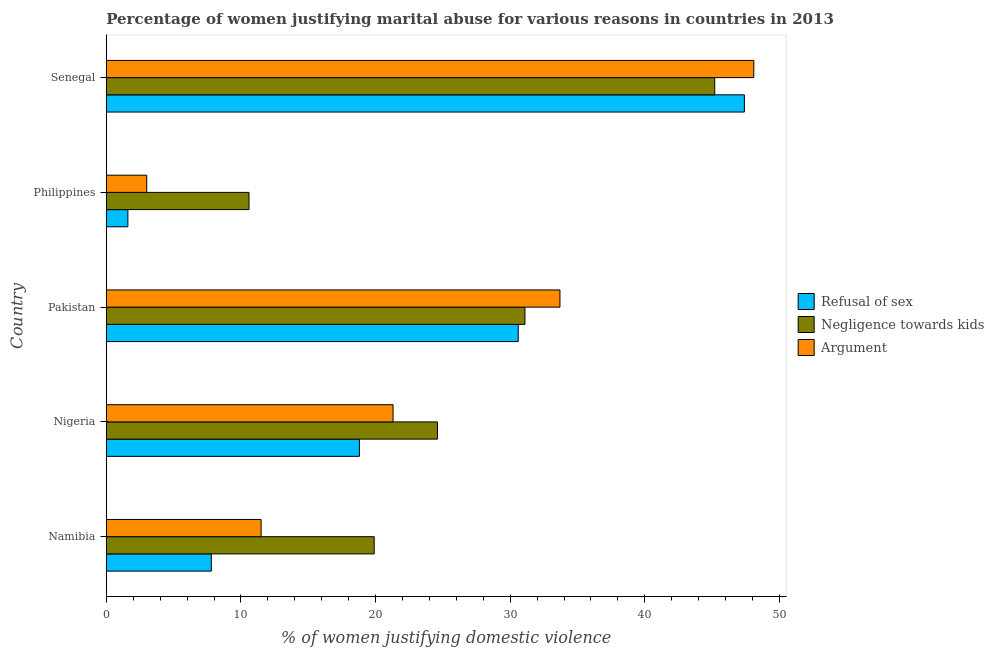How many different coloured bars are there?
Ensure brevity in your answer.  3. How many groups of bars are there?
Make the answer very short. 5. Are the number of bars per tick equal to the number of legend labels?
Keep it short and to the point. Yes. What is the label of the 5th group of bars from the top?
Offer a terse response. Namibia. What is the percentage of women justifying domestic violence due to arguments in Pakistan?
Provide a short and direct response. 33.7. Across all countries, what is the maximum percentage of women justifying domestic violence due to arguments?
Offer a terse response. 48.1. Across all countries, what is the minimum percentage of women justifying domestic violence due to arguments?
Provide a succinct answer. 3. In which country was the percentage of women justifying domestic violence due to refusal of sex maximum?
Give a very brief answer. Senegal. In which country was the percentage of women justifying domestic violence due to refusal of sex minimum?
Keep it short and to the point. Philippines. What is the total percentage of women justifying domestic violence due to arguments in the graph?
Your answer should be compact. 117.6. What is the difference between the percentage of women justifying domestic violence due to refusal of sex in Nigeria and the percentage of women justifying domestic violence due to arguments in Senegal?
Keep it short and to the point. -29.3. What is the average percentage of women justifying domestic violence due to arguments per country?
Your answer should be compact. 23.52. What is the ratio of the percentage of women justifying domestic violence due to refusal of sex in Pakistan to that in Senegal?
Give a very brief answer. 0.65. What is the difference between the highest and the second highest percentage of women justifying domestic violence due to refusal of sex?
Offer a terse response. 16.8. What is the difference between the highest and the lowest percentage of women justifying domestic violence due to arguments?
Provide a short and direct response. 45.1. In how many countries, is the percentage of women justifying domestic violence due to negligence towards kids greater than the average percentage of women justifying domestic violence due to negligence towards kids taken over all countries?
Make the answer very short. 2. Is the sum of the percentage of women justifying domestic violence due to arguments in Nigeria and Philippines greater than the maximum percentage of women justifying domestic violence due to refusal of sex across all countries?
Offer a very short reply. No. What does the 2nd bar from the top in Senegal represents?
Provide a short and direct response. Negligence towards kids. What does the 2nd bar from the bottom in Nigeria represents?
Keep it short and to the point. Negligence towards kids. How many countries are there in the graph?
Give a very brief answer. 5. What is the difference between two consecutive major ticks on the X-axis?
Your answer should be compact. 10. Are the values on the major ticks of X-axis written in scientific E-notation?
Ensure brevity in your answer.  No. Where does the legend appear in the graph?
Offer a terse response. Center right. How many legend labels are there?
Give a very brief answer. 3. How are the legend labels stacked?
Your response must be concise. Vertical. What is the title of the graph?
Keep it short and to the point. Percentage of women justifying marital abuse for various reasons in countries in 2013. What is the label or title of the X-axis?
Provide a short and direct response. % of women justifying domestic violence. What is the label or title of the Y-axis?
Make the answer very short. Country. What is the % of women justifying domestic violence in Negligence towards kids in Namibia?
Ensure brevity in your answer.  19.9. What is the % of women justifying domestic violence in Refusal of sex in Nigeria?
Keep it short and to the point. 18.8. What is the % of women justifying domestic violence of Negligence towards kids in Nigeria?
Offer a terse response. 24.6. What is the % of women justifying domestic violence in Argument in Nigeria?
Your answer should be compact. 21.3. What is the % of women justifying domestic violence of Refusal of sex in Pakistan?
Provide a short and direct response. 30.6. What is the % of women justifying domestic violence in Negligence towards kids in Pakistan?
Your answer should be compact. 31.1. What is the % of women justifying domestic violence of Argument in Pakistan?
Your answer should be compact. 33.7. What is the % of women justifying domestic violence of Refusal of sex in Philippines?
Offer a very short reply. 1.6. What is the % of women justifying domestic violence in Argument in Philippines?
Provide a succinct answer. 3. What is the % of women justifying domestic violence of Refusal of sex in Senegal?
Provide a succinct answer. 47.4. What is the % of women justifying domestic violence in Negligence towards kids in Senegal?
Ensure brevity in your answer.  45.2. What is the % of women justifying domestic violence in Argument in Senegal?
Offer a very short reply. 48.1. Across all countries, what is the maximum % of women justifying domestic violence of Refusal of sex?
Keep it short and to the point. 47.4. Across all countries, what is the maximum % of women justifying domestic violence of Negligence towards kids?
Your answer should be very brief. 45.2. Across all countries, what is the maximum % of women justifying domestic violence in Argument?
Provide a short and direct response. 48.1. Across all countries, what is the minimum % of women justifying domestic violence in Refusal of sex?
Your answer should be very brief. 1.6. Across all countries, what is the minimum % of women justifying domestic violence in Negligence towards kids?
Offer a very short reply. 10.6. What is the total % of women justifying domestic violence of Refusal of sex in the graph?
Give a very brief answer. 106.2. What is the total % of women justifying domestic violence in Negligence towards kids in the graph?
Your response must be concise. 131.4. What is the total % of women justifying domestic violence in Argument in the graph?
Ensure brevity in your answer.  117.6. What is the difference between the % of women justifying domestic violence in Refusal of sex in Namibia and that in Pakistan?
Your answer should be compact. -22.8. What is the difference between the % of women justifying domestic violence in Argument in Namibia and that in Pakistan?
Offer a very short reply. -22.2. What is the difference between the % of women justifying domestic violence in Negligence towards kids in Namibia and that in Philippines?
Your response must be concise. 9.3. What is the difference between the % of women justifying domestic violence of Argument in Namibia and that in Philippines?
Keep it short and to the point. 8.5. What is the difference between the % of women justifying domestic violence in Refusal of sex in Namibia and that in Senegal?
Offer a very short reply. -39.6. What is the difference between the % of women justifying domestic violence in Negligence towards kids in Namibia and that in Senegal?
Provide a succinct answer. -25.3. What is the difference between the % of women justifying domestic violence of Argument in Namibia and that in Senegal?
Offer a very short reply. -36.6. What is the difference between the % of women justifying domestic violence in Argument in Nigeria and that in Pakistan?
Your answer should be very brief. -12.4. What is the difference between the % of women justifying domestic violence of Negligence towards kids in Nigeria and that in Philippines?
Provide a short and direct response. 14. What is the difference between the % of women justifying domestic violence in Refusal of sex in Nigeria and that in Senegal?
Make the answer very short. -28.6. What is the difference between the % of women justifying domestic violence in Negligence towards kids in Nigeria and that in Senegal?
Offer a terse response. -20.6. What is the difference between the % of women justifying domestic violence of Argument in Nigeria and that in Senegal?
Offer a terse response. -26.8. What is the difference between the % of women justifying domestic violence of Refusal of sex in Pakistan and that in Philippines?
Your answer should be compact. 29. What is the difference between the % of women justifying domestic violence of Argument in Pakistan and that in Philippines?
Provide a succinct answer. 30.7. What is the difference between the % of women justifying domestic violence of Refusal of sex in Pakistan and that in Senegal?
Offer a terse response. -16.8. What is the difference between the % of women justifying domestic violence in Negligence towards kids in Pakistan and that in Senegal?
Ensure brevity in your answer.  -14.1. What is the difference between the % of women justifying domestic violence in Argument in Pakistan and that in Senegal?
Offer a terse response. -14.4. What is the difference between the % of women justifying domestic violence of Refusal of sex in Philippines and that in Senegal?
Keep it short and to the point. -45.8. What is the difference between the % of women justifying domestic violence of Negligence towards kids in Philippines and that in Senegal?
Give a very brief answer. -34.6. What is the difference between the % of women justifying domestic violence in Argument in Philippines and that in Senegal?
Keep it short and to the point. -45.1. What is the difference between the % of women justifying domestic violence in Refusal of sex in Namibia and the % of women justifying domestic violence in Negligence towards kids in Nigeria?
Your answer should be very brief. -16.8. What is the difference between the % of women justifying domestic violence of Refusal of sex in Namibia and the % of women justifying domestic violence of Argument in Nigeria?
Make the answer very short. -13.5. What is the difference between the % of women justifying domestic violence of Refusal of sex in Namibia and the % of women justifying domestic violence of Negligence towards kids in Pakistan?
Your response must be concise. -23.3. What is the difference between the % of women justifying domestic violence in Refusal of sex in Namibia and the % of women justifying domestic violence in Argument in Pakistan?
Offer a very short reply. -25.9. What is the difference between the % of women justifying domestic violence of Negligence towards kids in Namibia and the % of women justifying domestic violence of Argument in Pakistan?
Your answer should be very brief. -13.8. What is the difference between the % of women justifying domestic violence of Refusal of sex in Namibia and the % of women justifying domestic violence of Negligence towards kids in Philippines?
Provide a succinct answer. -2.8. What is the difference between the % of women justifying domestic violence in Negligence towards kids in Namibia and the % of women justifying domestic violence in Argument in Philippines?
Your response must be concise. 16.9. What is the difference between the % of women justifying domestic violence in Refusal of sex in Namibia and the % of women justifying domestic violence in Negligence towards kids in Senegal?
Your answer should be compact. -37.4. What is the difference between the % of women justifying domestic violence in Refusal of sex in Namibia and the % of women justifying domestic violence in Argument in Senegal?
Your response must be concise. -40.3. What is the difference between the % of women justifying domestic violence in Negligence towards kids in Namibia and the % of women justifying domestic violence in Argument in Senegal?
Your answer should be compact. -28.2. What is the difference between the % of women justifying domestic violence in Refusal of sex in Nigeria and the % of women justifying domestic violence in Negligence towards kids in Pakistan?
Offer a terse response. -12.3. What is the difference between the % of women justifying domestic violence in Refusal of sex in Nigeria and the % of women justifying domestic violence in Argument in Pakistan?
Provide a short and direct response. -14.9. What is the difference between the % of women justifying domestic violence in Refusal of sex in Nigeria and the % of women justifying domestic violence in Negligence towards kids in Philippines?
Make the answer very short. 8.2. What is the difference between the % of women justifying domestic violence of Refusal of sex in Nigeria and the % of women justifying domestic violence of Argument in Philippines?
Make the answer very short. 15.8. What is the difference between the % of women justifying domestic violence in Negligence towards kids in Nigeria and the % of women justifying domestic violence in Argument in Philippines?
Offer a terse response. 21.6. What is the difference between the % of women justifying domestic violence in Refusal of sex in Nigeria and the % of women justifying domestic violence in Negligence towards kids in Senegal?
Give a very brief answer. -26.4. What is the difference between the % of women justifying domestic violence of Refusal of sex in Nigeria and the % of women justifying domestic violence of Argument in Senegal?
Offer a very short reply. -29.3. What is the difference between the % of women justifying domestic violence of Negligence towards kids in Nigeria and the % of women justifying domestic violence of Argument in Senegal?
Offer a very short reply. -23.5. What is the difference between the % of women justifying domestic violence of Refusal of sex in Pakistan and the % of women justifying domestic violence of Negligence towards kids in Philippines?
Provide a short and direct response. 20. What is the difference between the % of women justifying domestic violence in Refusal of sex in Pakistan and the % of women justifying domestic violence in Argument in Philippines?
Offer a very short reply. 27.6. What is the difference between the % of women justifying domestic violence of Negligence towards kids in Pakistan and the % of women justifying domestic violence of Argument in Philippines?
Your answer should be very brief. 28.1. What is the difference between the % of women justifying domestic violence of Refusal of sex in Pakistan and the % of women justifying domestic violence of Negligence towards kids in Senegal?
Offer a very short reply. -14.6. What is the difference between the % of women justifying domestic violence of Refusal of sex in Pakistan and the % of women justifying domestic violence of Argument in Senegal?
Make the answer very short. -17.5. What is the difference between the % of women justifying domestic violence in Negligence towards kids in Pakistan and the % of women justifying domestic violence in Argument in Senegal?
Make the answer very short. -17. What is the difference between the % of women justifying domestic violence of Refusal of sex in Philippines and the % of women justifying domestic violence of Negligence towards kids in Senegal?
Your answer should be very brief. -43.6. What is the difference between the % of women justifying domestic violence in Refusal of sex in Philippines and the % of women justifying domestic violence in Argument in Senegal?
Give a very brief answer. -46.5. What is the difference between the % of women justifying domestic violence of Negligence towards kids in Philippines and the % of women justifying domestic violence of Argument in Senegal?
Provide a short and direct response. -37.5. What is the average % of women justifying domestic violence of Refusal of sex per country?
Your answer should be very brief. 21.24. What is the average % of women justifying domestic violence in Negligence towards kids per country?
Provide a succinct answer. 26.28. What is the average % of women justifying domestic violence of Argument per country?
Provide a short and direct response. 23.52. What is the difference between the % of women justifying domestic violence in Refusal of sex and % of women justifying domestic violence in Negligence towards kids in Namibia?
Give a very brief answer. -12.1. What is the difference between the % of women justifying domestic violence of Negligence towards kids and % of women justifying domestic violence of Argument in Namibia?
Your answer should be compact. 8.4. What is the difference between the % of women justifying domestic violence of Refusal of sex and % of women justifying domestic violence of Argument in Nigeria?
Offer a very short reply. -2.5. What is the difference between the % of women justifying domestic violence in Negligence towards kids and % of women justifying domestic violence in Argument in Nigeria?
Offer a very short reply. 3.3. What is the difference between the % of women justifying domestic violence of Refusal of sex and % of women justifying domestic violence of Argument in Pakistan?
Make the answer very short. -3.1. What is the difference between the % of women justifying domestic violence of Negligence towards kids and % of women justifying domestic violence of Argument in Pakistan?
Give a very brief answer. -2.6. What is the difference between the % of women justifying domestic violence in Refusal of sex and % of women justifying domestic violence in Negligence towards kids in Philippines?
Provide a short and direct response. -9. What is the difference between the % of women justifying domestic violence of Refusal of sex and % of women justifying domestic violence of Argument in Senegal?
Offer a terse response. -0.7. What is the ratio of the % of women justifying domestic violence of Refusal of sex in Namibia to that in Nigeria?
Your response must be concise. 0.41. What is the ratio of the % of women justifying domestic violence in Negligence towards kids in Namibia to that in Nigeria?
Offer a very short reply. 0.81. What is the ratio of the % of women justifying domestic violence of Argument in Namibia to that in Nigeria?
Offer a terse response. 0.54. What is the ratio of the % of women justifying domestic violence of Refusal of sex in Namibia to that in Pakistan?
Your answer should be compact. 0.25. What is the ratio of the % of women justifying domestic violence in Negligence towards kids in Namibia to that in Pakistan?
Give a very brief answer. 0.64. What is the ratio of the % of women justifying domestic violence in Argument in Namibia to that in Pakistan?
Provide a succinct answer. 0.34. What is the ratio of the % of women justifying domestic violence in Refusal of sex in Namibia to that in Philippines?
Your answer should be very brief. 4.88. What is the ratio of the % of women justifying domestic violence of Negligence towards kids in Namibia to that in Philippines?
Your answer should be very brief. 1.88. What is the ratio of the % of women justifying domestic violence in Argument in Namibia to that in Philippines?
Make the answer very short. 3.83. What is the ratio of the % of women justifying domestic violence in Refusal of sex in Namibia to that in Senegal?
Make the answer very short. 0.16. What is the ratio of the % of women justifying domestic violence in Negligence towards kids in Namibia to that in Senegal?
Your response must be concise. 0.44. What is the ratio of the % of women justifying domestic violence of Argument in Namibia to that in Senegal?
Your response must be concise. 0.24. What is the ratio of the % of women justifying domestic violence of Refusal of sex in Nigeria to that in Pakistan?
Your answer should be very brief. 0.61. What is the ratio of the % of women justifying domestic violence in Negligence towards kids in Nigeria to that in Pakistan?
Offer a terse response. 0.79. What is the ratio of the % of women justifying domestic violence of Argument in Nigeria to that in Pakistan?
Your answer should be compact. 0.63. What is the ratio of the % of women justifying domestic violence of Refusal of sex in Nigeria to that in Philippines?
Your answer should be compact. 11.75. What is the ratio of the % of women justifying domestic violence in Negligence towards kids in Nigeria to that in Philippines?
Ensure brevity in your answer.  2.32. What is the ratio of the % of women justifying domestic violence of Argument in Nigeria to that in Philippines?
Your answer should be compact. 7.1. What is the ratio of the % of women justifying domestic violence in Refusal of sex in Nigeria to that in Senegal?
Provide a succinct answer. 0.4. What is the ratio of the % of women justifying domestic violence of Negligence towards kids in Nigeria to that in Senegal?
Give a very brief answer. 0.54. What is the ratio of the % of women justifying domestic violence in Argument in Nigeria to that in Senegal?
Keep it short and to the point. 0.44. What is the ratio of the % of women justifying domestic violence of Refusal of sex in Pakistan to that in Philippines?
Give a very brief answer. 19.12. What is the ratio of the % of women justifying domestic violence in Negligence towards kids in Pakistan to that in Philippines?
Your response must be concise. 2.93. What is the ratio of the % of women justifying domestic violence of Argument in Pakistan to that in Philippines?
Provide a succinct answer. 11.23. What is the ratio of the % of women justifying domestic violence of Refusal of sex in Pakistan to that in Senegal?
Keep it short and to the point. 0.65. What is the ratio of the % of women justifying domestic violence in Negligence towards kids in Pakistan to that in Senegal?
Give a very brief answer. 0.69. What is the ratio of the % of women justifying domestic violence in Argument in Pakistan to that in Senegal?
Make the answer very short. 0.7. What is the ratio of the % of women justifying domestic violence of Refusal of sex in Philippines to that in Senegal?
Your answer should be very brief. 0.03. What is the ratio of the % of women justifying domestic violence in Negligence towards kids in Philippines to that in Senegal?
Offer a terse response. 0.23. What is the ratio of the % of women justifying domestic violence in Argument in Philippines to that in Senegal?
Give a very brief answer. 0.06. What is the difference between the highest and the second highest % of women justifying domestic violence of Negligence towards kids?
Your response must be concise. 14.1. What is the difference between the highest and the lowest % of women justifying domestic violence in Refusal of sex?
Offer a very short reply. 45.8. What is the difference between the highest and the lowest % of women justifying domestic violence in Negligence towards kids?
Your answer should be compact. 34.6. What is the difference between the highest and the lowest % of women justifying domestic violence of Argument?
Offer a very short reply. 45.1. 